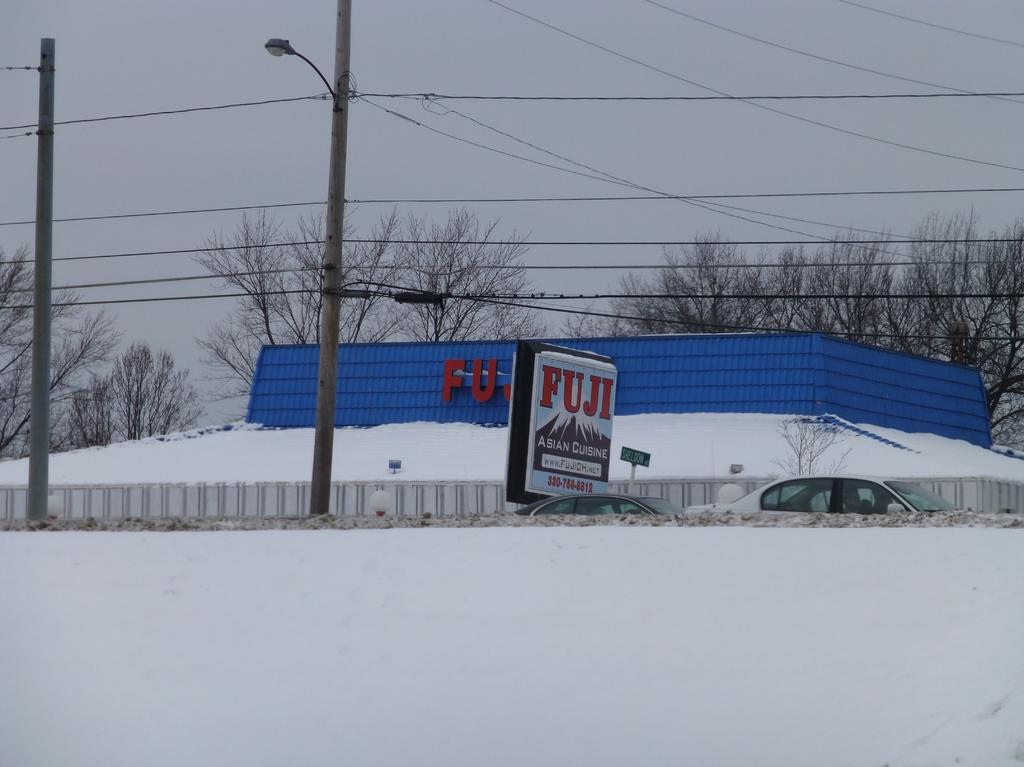How many letters are in the name of this restaurant?
Ensure brevity in your answer.  4. What is the name of this restaurant?
Give a very brief answer. Fuji. 